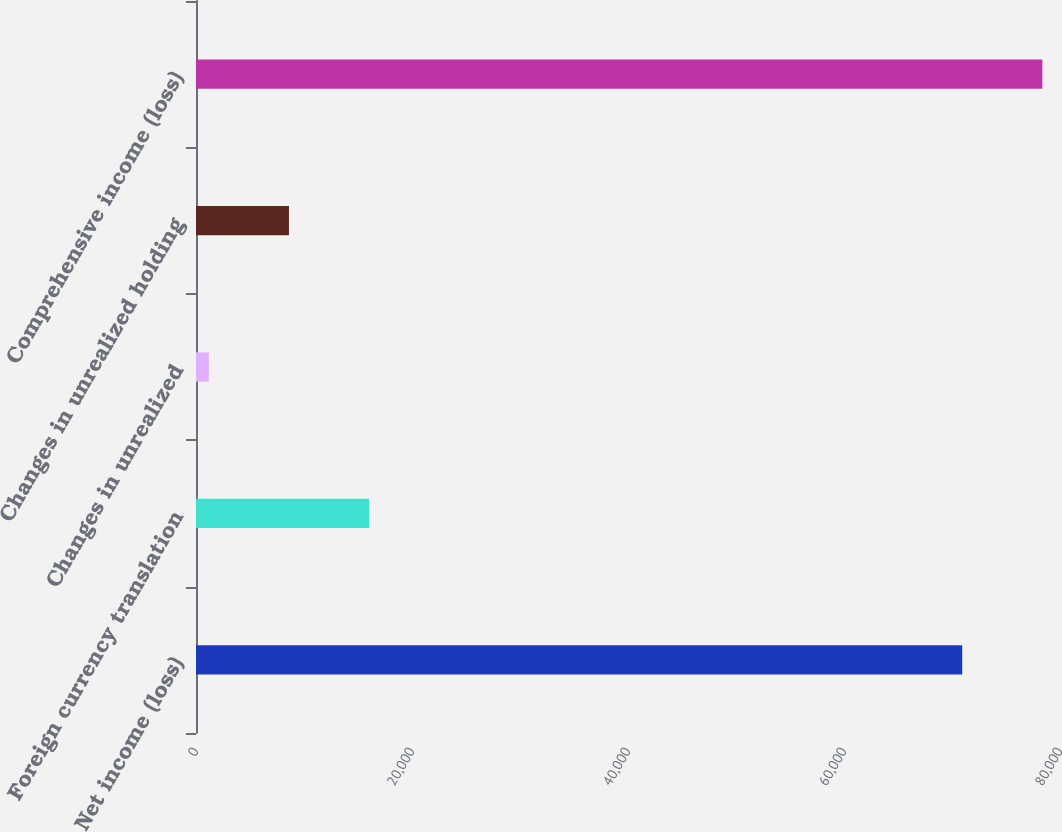<chart> <loc_0><loc_0><loc_500><loc_500><bar_chart><fcel>Net income (loss)<fcel>Foreign currency translation<fcel>Changes in unrealized<fcel>Changes in unrealized holding<fcel>Comprehensive income (loss)<nl><fcel>70946<fcel>16026.6<fcel>1188<fcel>8607.3<fcel>78365.3<nl></chart> 